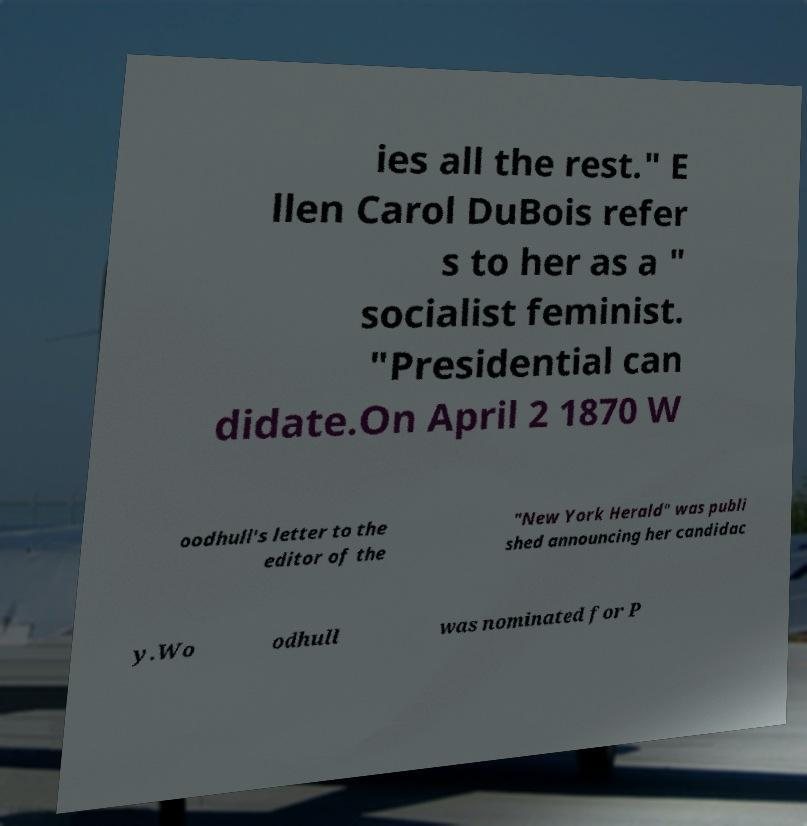Please read and relay the text visible in this image. What does it say? ies all the rest." E llen Carol DuBois refer s to her as a " socialist feminist. "Presidential can didate.On April 2 1870 W oodhull's letter to the editor of the "New York Herald" was publi shed announcing her candidac y.Wo odhull was nominated for P 